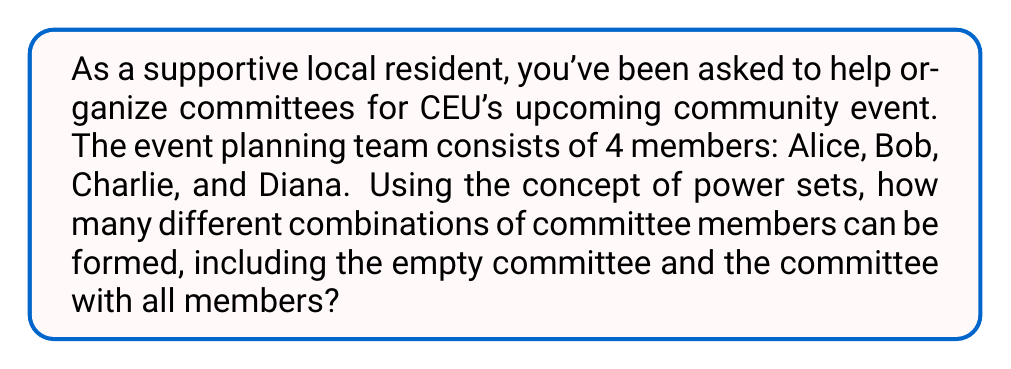Provide a solution to this math problem. To solve this problem, we need to understand the concept of power sets and how it applies to forming committees.

1) First, let's define our set:
   $S = \{Alice, Bob, Charlie, Diana\}$

2) The power set of S, denoted as $P(S)$, is the set of all possible subsets of S, including the empty set and S itself.

3) For a set with n elements, the number of elements in its power set is given by $2^n$. This is because for each element, we have two choices: include it in the subset or not.

4) In our case, $n = 4$ (Alice, Bob, Charlie, and Diana).

5) Therefore, the number of elements in the power set, which represents all possible committee combinations, is:

   $|P(S)| = 2^4 = 16$

6) To verify, we can list all possible combinations:
   - Empty committee: $\{\}$
   - 1-member committees: $\{A\}, \{B\}, \{C\}, \{D\}$
   - 2-member committees: $\{A,B\}, \{A,C\}, \{A,D\}, \{B,C\}, \{B,D\}, \{C,D\}$
   - 3-member committees: $\{A,B,C\}, \{A,B,D\}, \{A,C,D\}, \{B,C,D\}$
   - Full committee: $\{A,B,C,D\}$

   Indeed, we have 16 different combinations in total.
Answer: The number of different combinations of committee members that can be formed is $2^4 = 16$. 